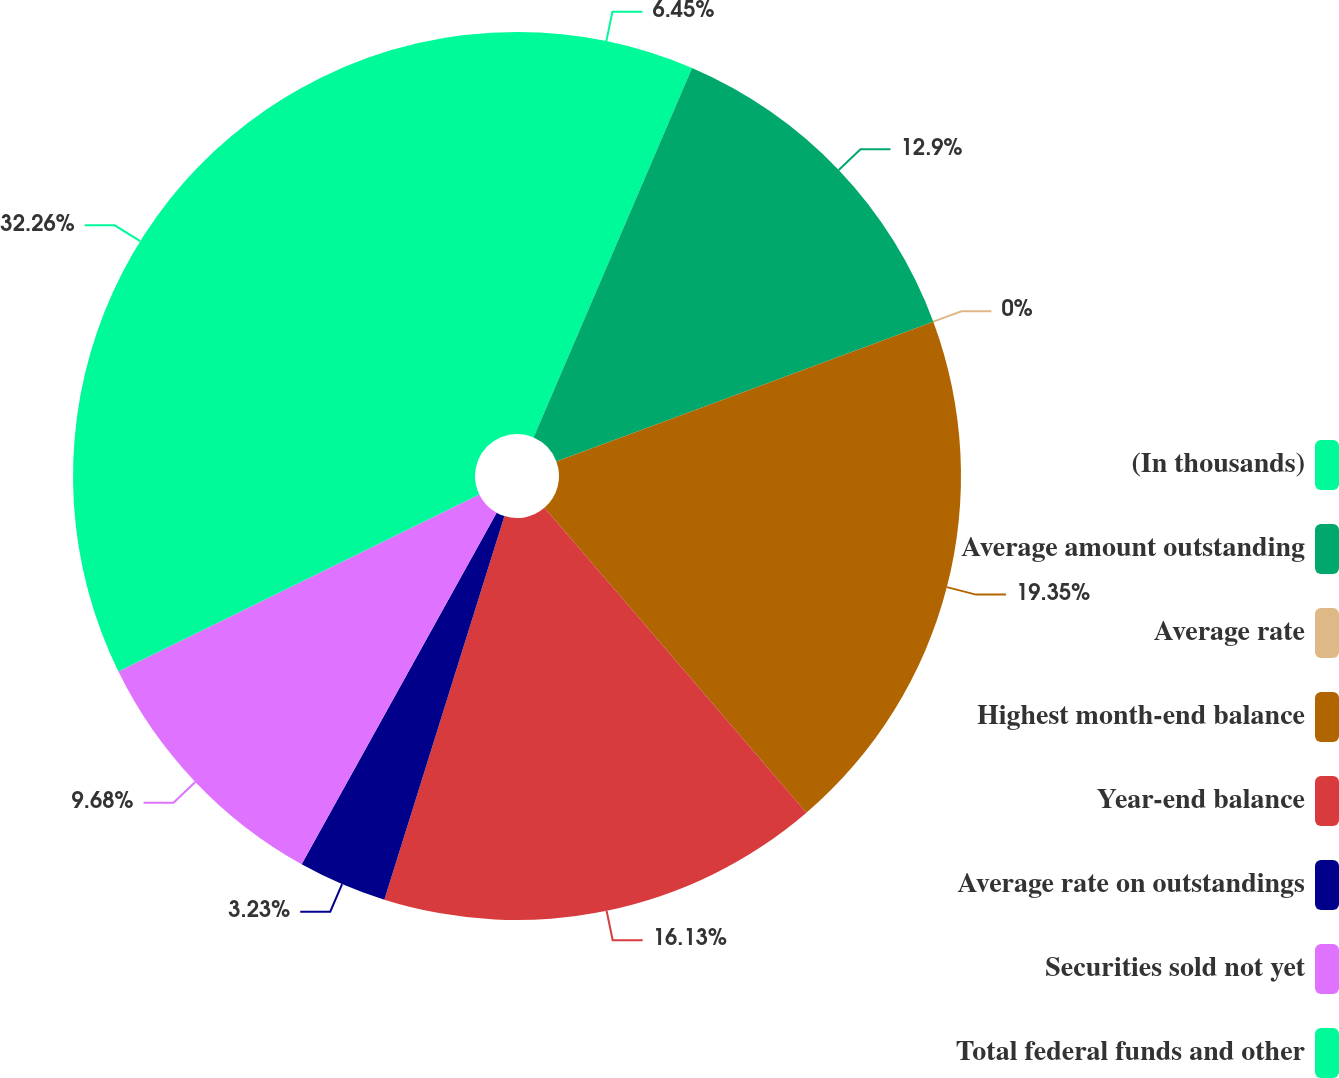Convert chart. <chart><loc_0><loc_0><loc_500><loc_500><pie_chart><fcel>(In thousands)<fcel>Average amount outstanding<fcel>Average rate<fcel>Highest month-end balance<fcel>Year-end balance<fcel>Average rate on outstandings<fcel>Securities sold not yet<fcel>Total federal funds and other<nl><fcel>6.45%<fcel>12.9%<fcel>0.0%<fcel>19.35%<fcel>16.13%<fcel>3.23%<fcel>9.68%<fcel>32.26%<nl></chart> 